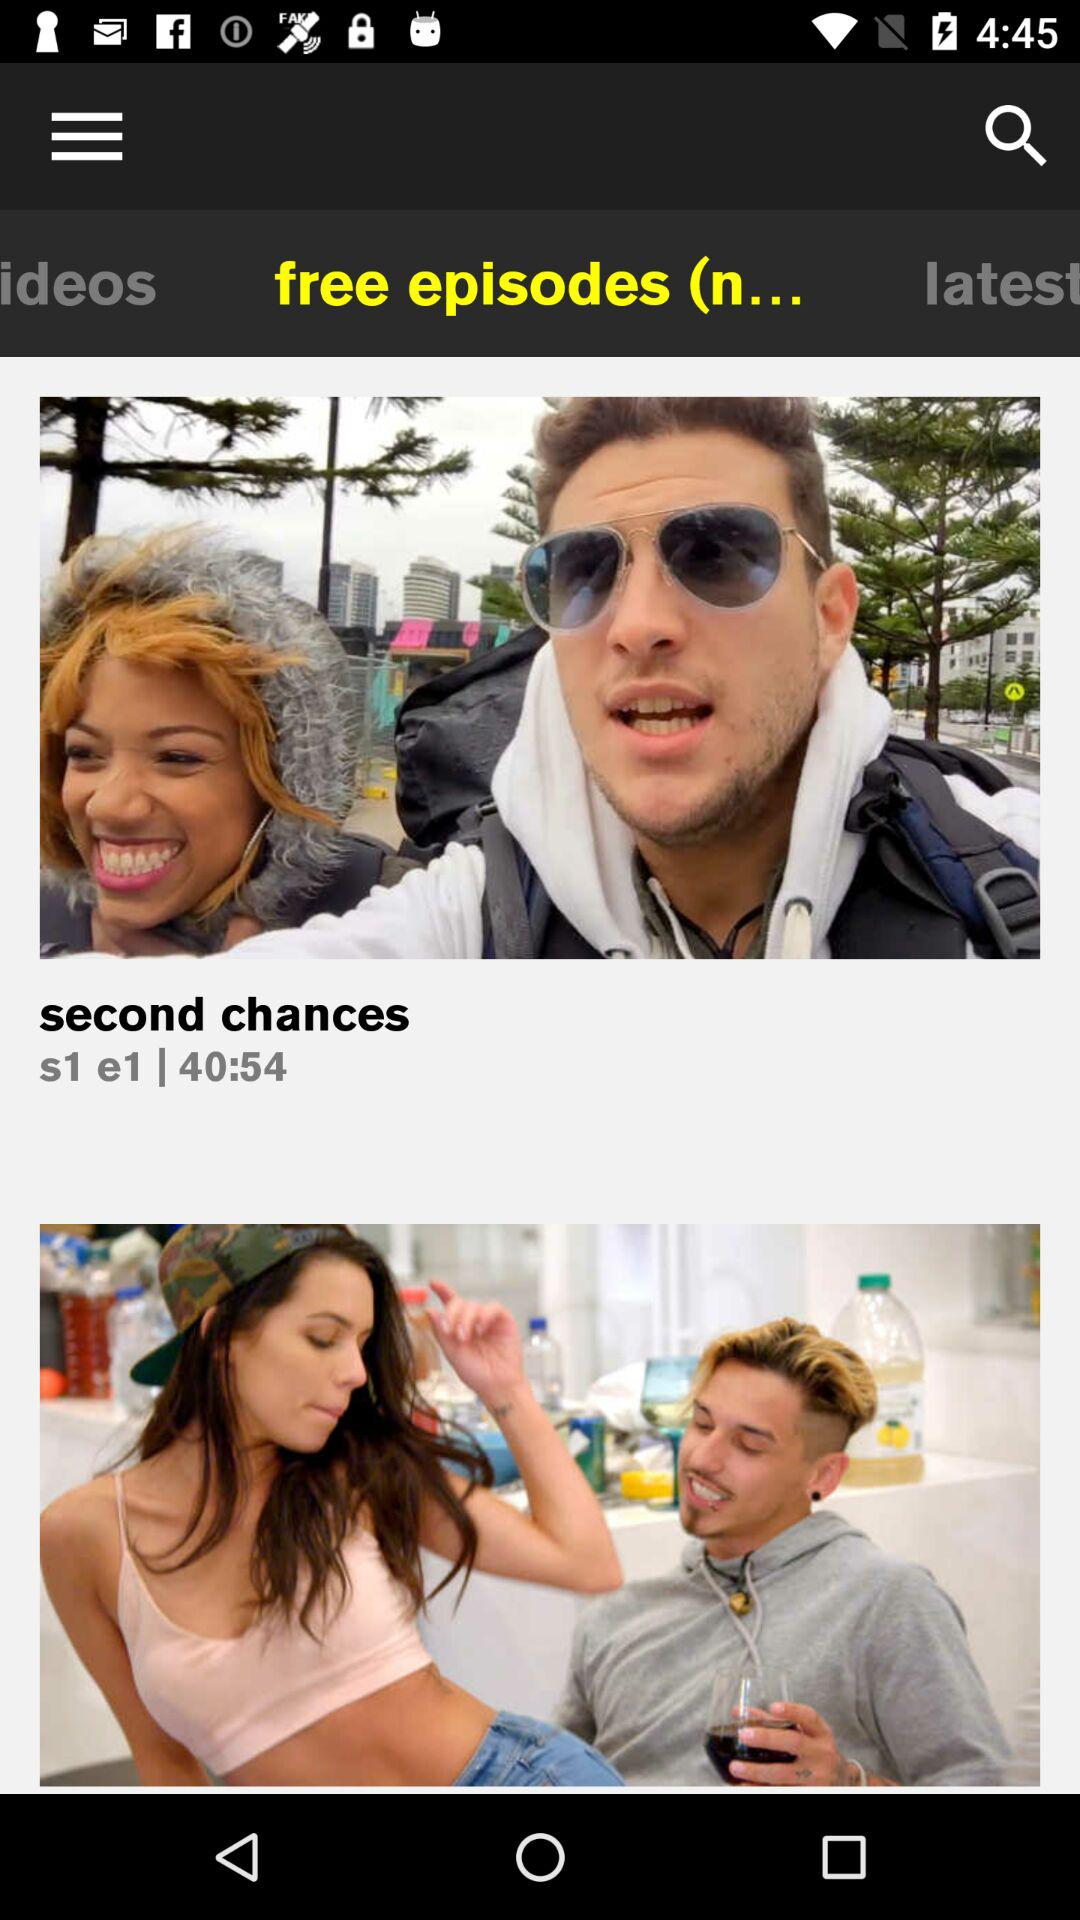What is the time duration of the episode? The time duration is 40 minutes 54 seconds. 